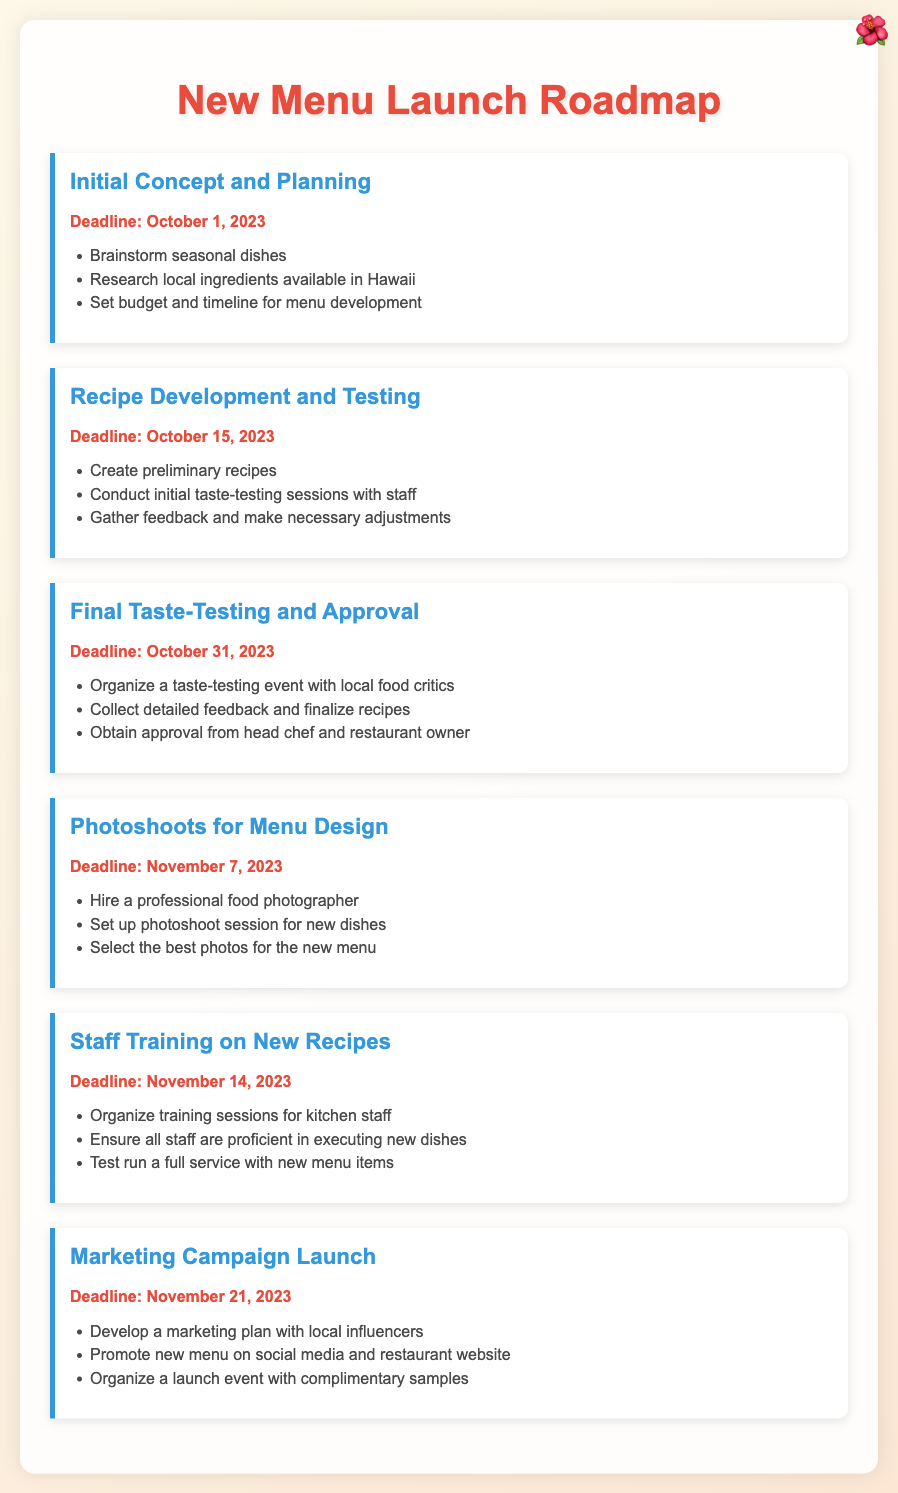What is the deadline for the Initial Concept and Planning phase? The deadline for the Initial Concept and Planning phase is clearly stated in the document.
Answer: October 1, 2023 What are the main tasks for the Recipe Development and Testing milestone? The document lists specific tasks to complete during the Recipe Development and Testing phase.
Answer: Create preliminary recipes, conduct initial taste-testing sessions with staff, gather feedback and make necessary adjustments Who needs to approve the recipes after the Final Taste-Testing? The document mentions who is responsible for approving the recipes following the Final Taste-Testing.
Answer: Head chef and restaurant owner What is the deadline for the Marketing Campaign Launch? The deadline for the Marketing Campaign Launch is provided in the document, indicating when this task should be completed.
Answer: November 21, 2023 What is the purpose of photoshoots in the new menu launch? The document explains the role of photoshoots in the context of the new menu launch.
Answer: To select the best photos for the new menu How many phases are included in the New Menu Launch Roadmap? The document outlines distinct phases in the itinerary, allowing for an easy count.
Answer: Six phases 